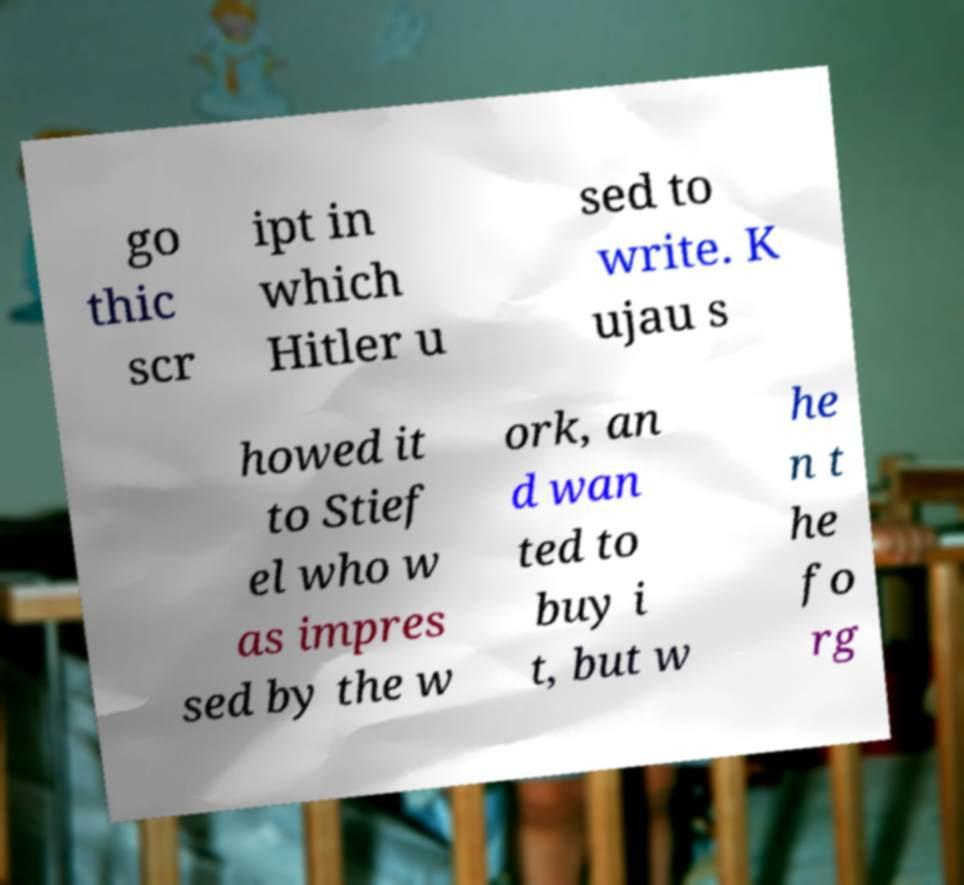Could you extract and type out the text from this image? go thic scr ipt in which Hitler u sed to write. K ujau s howed it to Stief el who w as impres sed by the w ork, an d wan ted to buy i t, but w he n t he fo rg 